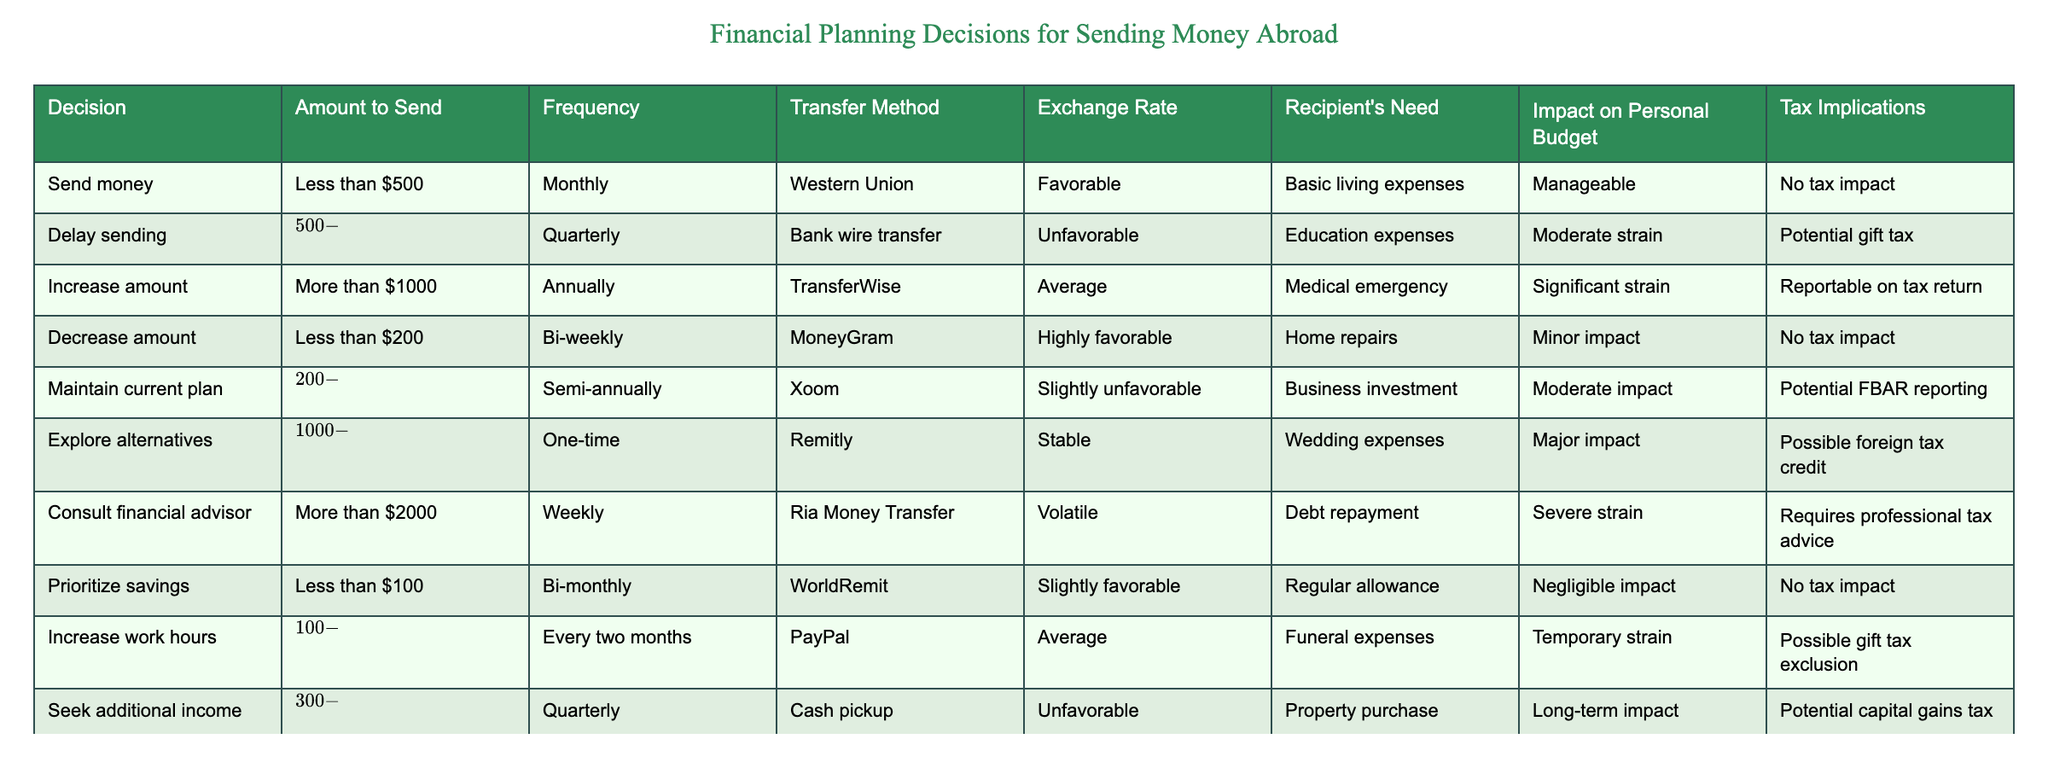What is the maximum amount to send according to the table? The decision to send money involves a maximum amount of more than $2000, represented by the decision "Consult financial advisor." This is the highest value indicated in the "Amount to Send" column.
Answer: More than $2000 What transfer method is used when sending less than $200? The transfer method for sending less than $200 is "MoneyGram," according to the data in the corresponding row of the table.
Answer: MoneyGram Is there any tax impact when sending between $200 and $500? Yes, it indicates "Potential FBAR reporting," meaning it could have tax implications that require attention according to the decision "Maintain current plan."
Answer: Yes Which decision has the most significant impact on the personal budget? The decision "Consult financial advisor" has the most significant impact, listed as "Severe strain" on the personal budget, compared to other decisions.
Answer: Severe strain How often is money sent when the decision is to increase the amount for funeral expenses? The frequency for increasing the amount to send for funeral expenses is "Every two months" as stated in the line referring to the decision "Increase work hours."
Answer: Every two months Which decision corresponds to a favorable exchange rate for sending money? The first decision in the table, "Send money," corresponds to a favorable exchange rate, as noted in the "Exchange Rate" column.
Answer: Favorable What is the impact on personal budget when the decision is to seek additional income? The impact noted for the decision "Seek additional income" is described as a "Long-term impact," suggesting a substantial effect on financial planning over time.
Answer: Long-term impact If one were to delay sending money between $500 and $1000, what are the tax implications? The tax implications for delaying sending money in this range would be a "Potential gift tax," indicating that there may be tax obligations to consider.
Answer: Potential gift tax What is the average amount range for the decisions related to semi-annual sending frequency? There are two decisions with semi-annual frequency: "Maintain current plan" and another with an amount between $200 and $500, which contributes to an average range of approximately $350 for both decisions in that bracket.
Answer: Approximately $350 